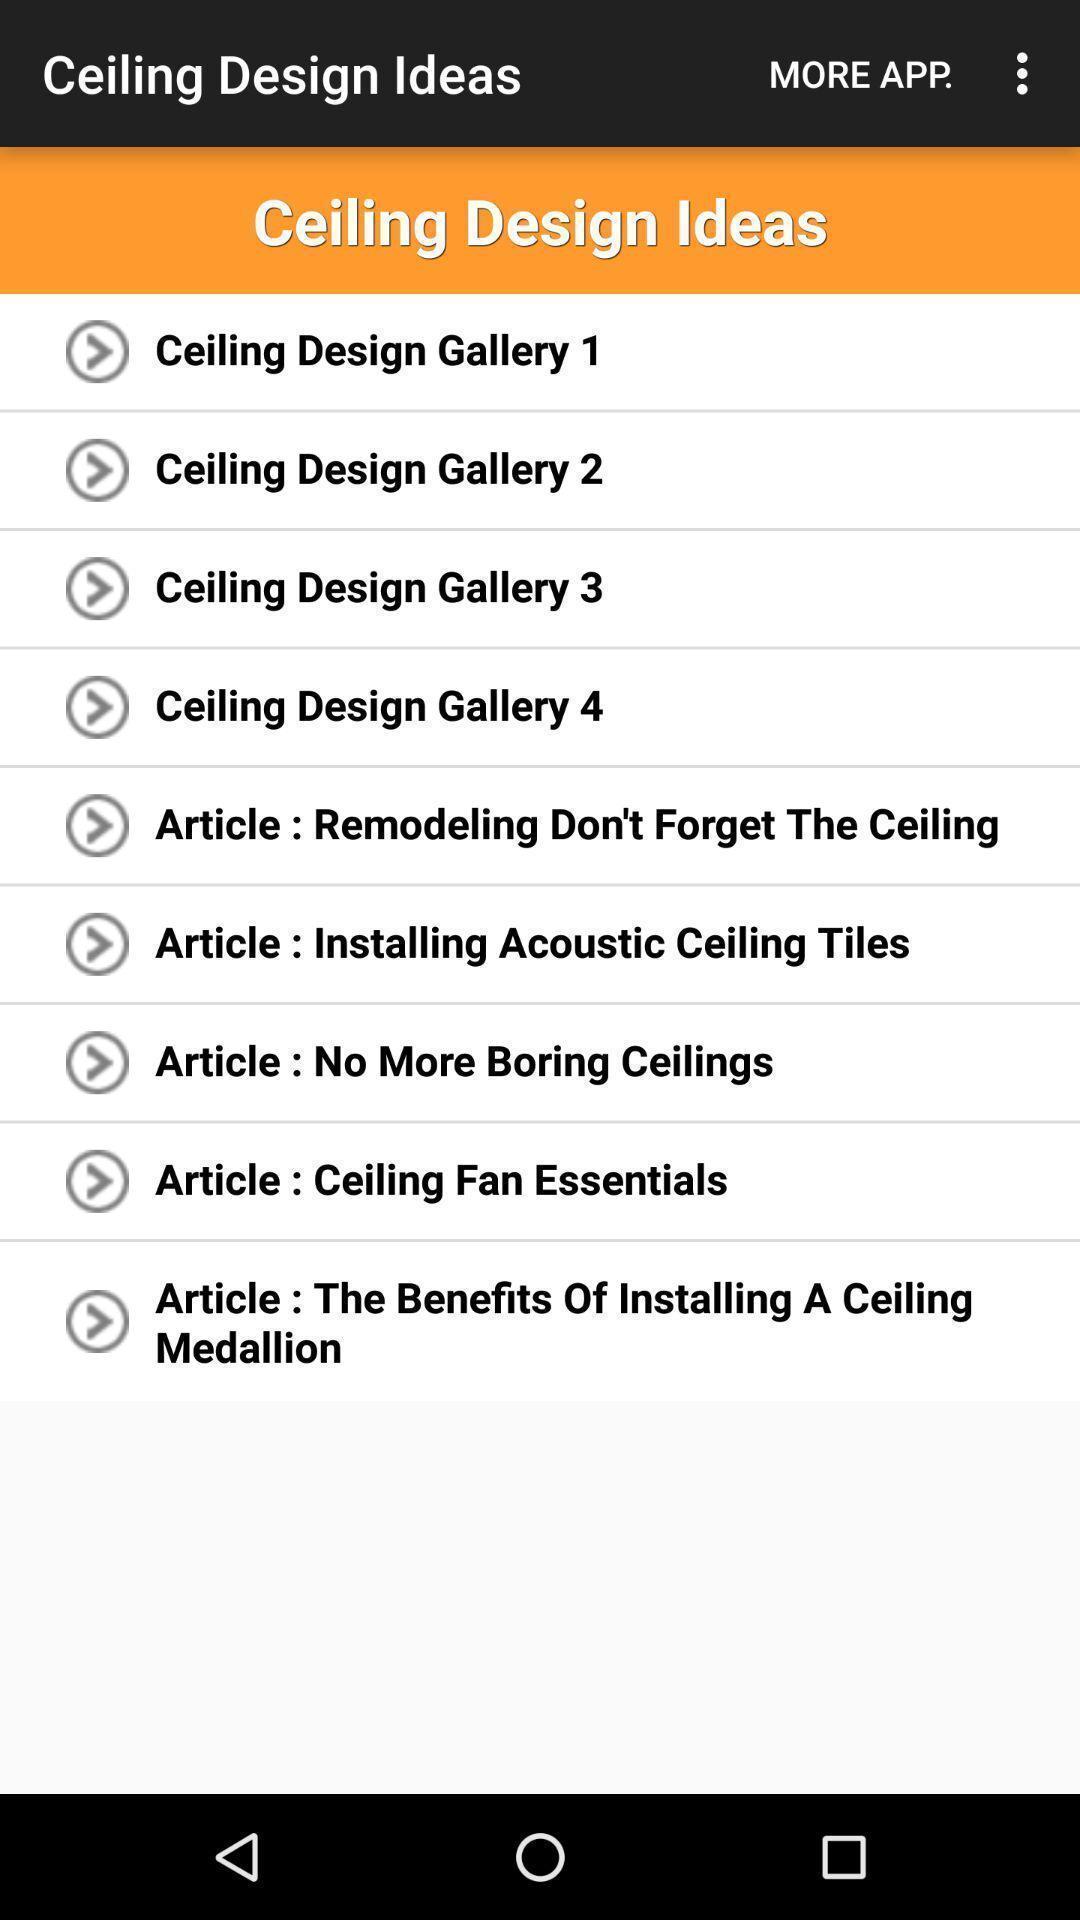What can you discern from this picture? Page displaying multiple options. 